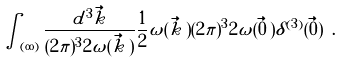<formula> <loc_0><loc_0><loc_500><loc_500>\int _ { ( \infty ) } \frac { d ^ { 3 } \vec { k } } { ( 2 \pi ) ^ { 3 } 2 \omega ( \vec { k } \, ) } \frac { 1 } { 2 } \omega ( \vec { k } \, ) ( 2 \pi ) ^ { 3 } 2 \omega ( \vec { 0 } \, ) \delta ^ { ( 3 ) } ( \vec { 0 } ) \ .</formula> 